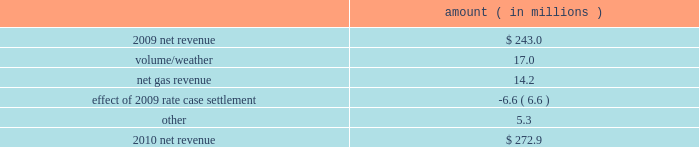Entergy new orleans , inc .
Management 2019s financial discussion and analysis the volume/weather variance is primarily due to an increase in electricity usage in the residential and commercial sectors due in part to a 4% ( 4 % ) increase in the average number of residential customers and a 3% ( 3 % ) increase in the average number of commercial customers , partially offset by the effect of less favorable weather on residential sales .
Gross operating revenues gross operating revenues decreased primarily due to : a decrease of $ 16.2 million in electric fuel cost recovery revenues due to lower fuel rates ; a decrease of $ 15.4 million in gross gas revenues primarily due to lower fuel cost recovery revenues as a result of lower fuel rates and the effect of milder weather ; and formula rate plan decreases effective october 2010 and october 2011 , as discussed above .
The decrease was partially offset by an increase in gross wholesale revenue due to increased sales to affiliated customers and more favorable volume/weather , as discussed above .
2010 compared to 2009 net revenue consists of operating revenues net of : 1 ) fuel , fuel-related expenses , and gas purchased for resale , 2 ) purchased power expenses , and 3 ) other regulatory charges ( credits ) .
Following is an analysis of the change in net revenue comparing 2010 to 2009 .
Amount ( in millions ) .
The volume/weather variance is primarily due to an increase of 348 gwh , or 7% ( 7 % ) , in billed retail electricity usage primarily due to more favorable weather compared to last year .
The net gas revenue variance is primarily due to more favorable weather compared to last year , along with the recognition of a gas regulatory asset associated with the settlement of entergy new orleans 2019s electric and gas formula rate plans .
See note 2 to the financial statements for further discussion of the formula rate plan settlement .
The effect of 2009 rate case settlement variance results from the april 2009 settlement of entergy new orleans 2019s rate case , and includes the effects of realigning non-fuel costs associated with the operation of grand gulf from the fuel adjustment clause to electric base rates effective june 2009 .
See note 2 to the financial statements for further discussion of the rate case settlement .
Other income statement variances 2011 compared to 2010 other operation and maintenance expenses decreased primarily due to the deferral in 2011 of $ 13.4 million of 2010 michoud plant maintenance costs pursuant to the settlement of entergy new orleans 2019s 2010 test year formula rate plan filing approved by the city council in september 2011 and a decrease of $ 8.0 million in fossil- fueled generation expenses due to higher plant outage costs in 2010 due to a greater scope of work at the michoud plant .
See note 2 to the financial statements for more discussion of the 2010 test year formula rate plan filing. .
What was the total net revenue between 2009 and 2010? 
Rationale: [3] : gross operating revenues gross operating revenues decreased primarily due to : a decrease of $ 16.2 million in electric fuel cost recovery revenues due to lower fuel rates ; a decrease of $ 15.4 million in gross gas revenues primarily due to lower fue
Computations: (272.9 + 243.0)
Answer: 515.9. 